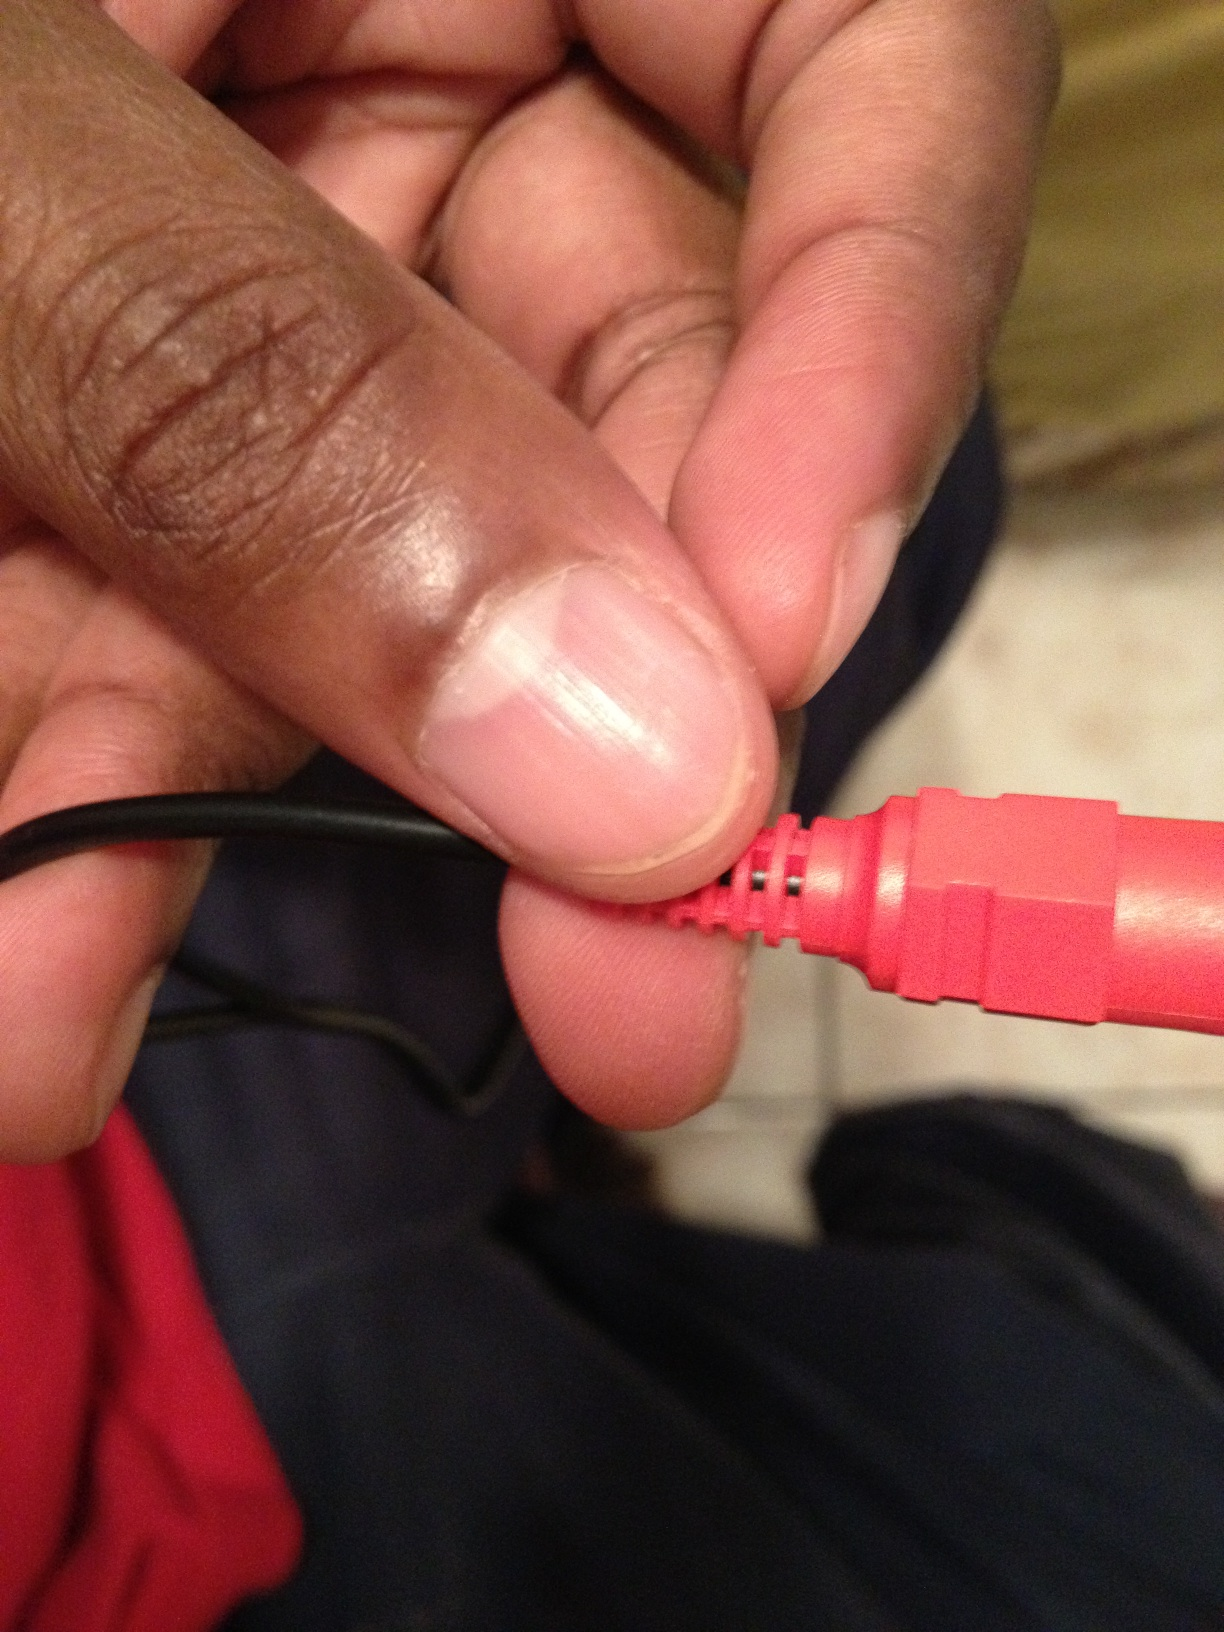If this pin were part of a futuristic device, what kind of device would it be? Imagine a futuristic, all-in-one personal assistant device, seamlessly integrating AI with daily life. This pin could be part of a sleek, compact module that connects augmented reality glasses, biometric sensors, and advanced communication hubs, turning simple gestures into powerful commands. What innovative features might this futuristic device have? This futuristic device could feature holographic displays, real-time language translation, health monitoring with immediate diagnostics, and seamless integration with smart home systems. It might even project immersive virtual environments for gaming or relaxation, adapting to your surroundings instantly. How could this futuristic device change everyday life? Such a device could revolutionize daily routines by providing instant access to information, personalized health insights, and augmented reality for enhanced productivity and entertainment. It could assist with tasks ranging from managing schedules and reminders to offering immersive learning experiences and facilitating effortless global communication. 